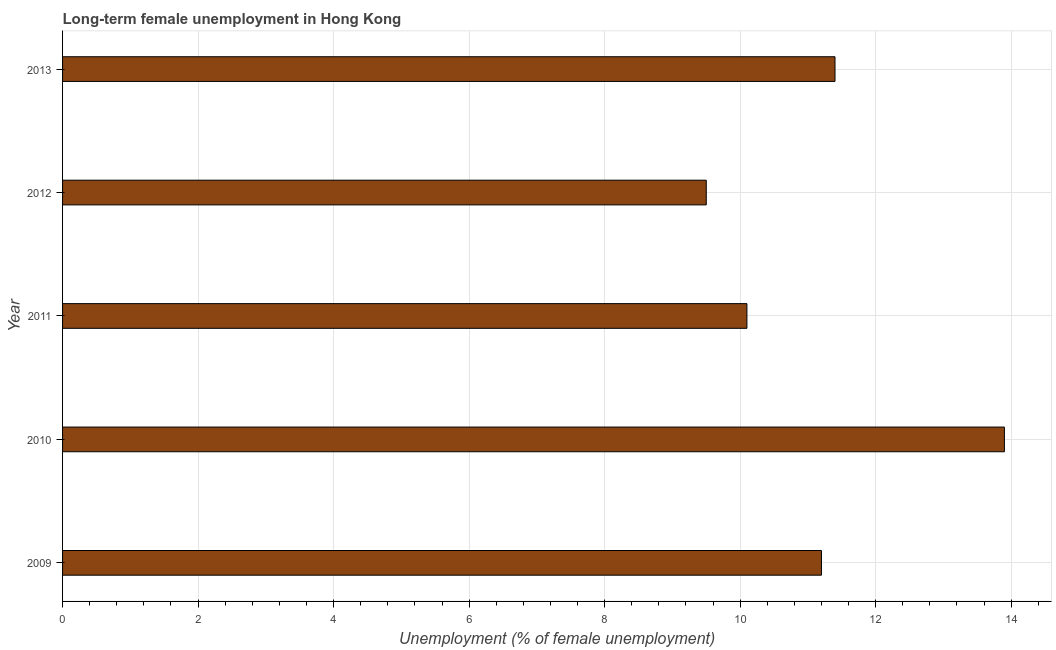Does the graph contain any zero values?
Give a very brief answer. No. Does the graph contain grids?
Your answer should be compact. Yes. What is the title of the graph?
Give a very brief answer. Long-term female unemployment in Hong Kong. What is the label or title of the X-axis?
Ensure brevity in your answer.  Unemployment (% of female unemployment). What is the long-term female unemployment in 2010?
Give a very brief answer. 13.9. Across all years, what is the maximum long-term female unemployment?
Ensure brevity in your answer.  13.9. In which year was the long-term female unemployment minimum?
Provide a short and direct response. 2012. What is the sum of the long-term female unemployment?
Ensure brevity in your answer.  56.1. What is the average long-term female unemployment per year?
Offer a very short reply. 11.22. What is the median long-term female unemployment?
Offer a terse response. 11.2. In how many years, is the long-term female unemployment greater than 11.6 %?
Offer a terse response. 1. Do a majority of the years between 2009 and 2010 (inclusive) have long-term female unemployment greater than 11.6 %?
Your answer should be compact. No. What is the ratio of the long-term female unemployment in 2009 to that in 2011?
Offer a terse response. 1.11. Is the difference between the long-term female unemployment in 2010 and 2012 greater than the difference between any two years?
Your response must be concise. Yes. What is the difference between the highest and the second highest long-term female unemployment?
Your response must be concise. 2.5. Is the sum of the long-term female unemployment in 2012 and 2013 greater than the maximum long-term female unemployment across all years?
Make the answer very short. Yes. Are all the bars in the graph horizontal?
Keep it short and to the point. Yes. What is the difference between two consecutive major ticks on the X-axis?
Give a very brief answer. 2. What is the Unemployment (% of female unemployment) of 2009?
Keep it short and to the point. 11.2. What is the Unemployment (% of female unemployment) of 2010?
Offer a terse response. 13.9. What is the Unemployment (% of female unemployment) in 2011?
Give a very brief answer. 10.1. What is the Unemployment (% of female unemployment) of 2013?
Provide a short and direct response. 11.4. What is the difference between the Unemployment (% of female unemployment) in 2009 and 2010?
Give a very brief answer. -2.7. What is the difference between the Unemployment (% of female unemployment) in 2009 and 2011?
Ensure brevity in your answer.  1.1. What is the difference between the Unemployment (% of female unemployment) in 2009 and 2013?
Keep it short and to the point. -0.2. What is the difference between the Unemployment (% of female unemployment) in 2010 and 2013?
Make the answer very short. 2.5. What is the difference between the Unemployment (% of female unemployment) in 2011 and 2013?
Ensure brevity in your answer.  -1.3. What is the ratio of the Unemployment (% of female unemployment) in 2009 to that in 2010?
Keep it short and to the point. 0.81. What is the ratio of the Unemployment (% of female unemployment) in 2009 to that in 2011?
Your response must be concise. 1.11. What is the ratio of the Unemployment (% of female unemployment) in 2009 to that in 2012?
Your response must be concise. 1.18. What is the ratio of the Unemployment (% of female unemployment) in 2009 to that in 2013?
Ensure brevity in your answer.  0.98. What is the ratio of the Unemployment (% of female unemployment) in 2010 to that in 2011?
Your answer should be very brief. 1.38. What is the ratio of the Unemployment (% of female unemployment) in 2010 to that in 2012?
Your response must be concise. 1.46. What is the ratio of the Unemployment (% of female unemployment) in 2010 to that in 2013?
Ensure brevity in your answer.  1.22. What is the ratio of the Unemployment (% of female unemployment) in 2011 to that in 2012?
Provide a succinct answer. 1.06. What is the ratio of the Unemployment (% of female unemployment) in 2011 to that in 2013?
Make the answer very short. 0.89. What is the ratio of the Unemployment (% of female unemployment) in 2012 to that in 2013?
Give a very brief answer. 0.83. 